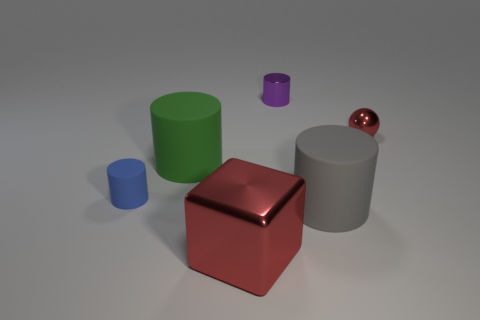Do the large metal thing and the tiny ball have the same color?
Give a very brief answer. Yes. Is the number of red things that are behind the big gray rubber cylinder greater than the number of small purple objects that are in front of the purple shiny thing?
Provide a short and direct response. Yes. What color is the tiny metal thing on the left side of the gray matte object?
Offer a terse response. Purple. Are there any small blue matte objects that have the same shape as the purple object?
Your response must be concise. Yes. How many blue things are tiny metal spheres or matte cubes?
Your answer should be compact. 0. Are there any metal balls that have the same size as the blue cylinder?
Your response must be concise. Yes. What number of tiny red metallic spheres are there?
Provide a short and direct response. 1. How many big things are either blocks or brown things?
Your response must be concise. 1. What is the color of the tiny cylinder that is behind the small metal thing on the right side of the tiny thing behind the sphere?
Offer a very short reply. Purple. How many other things are the same color as the shiny cylinder?
Provide a succinct answer. 0. 